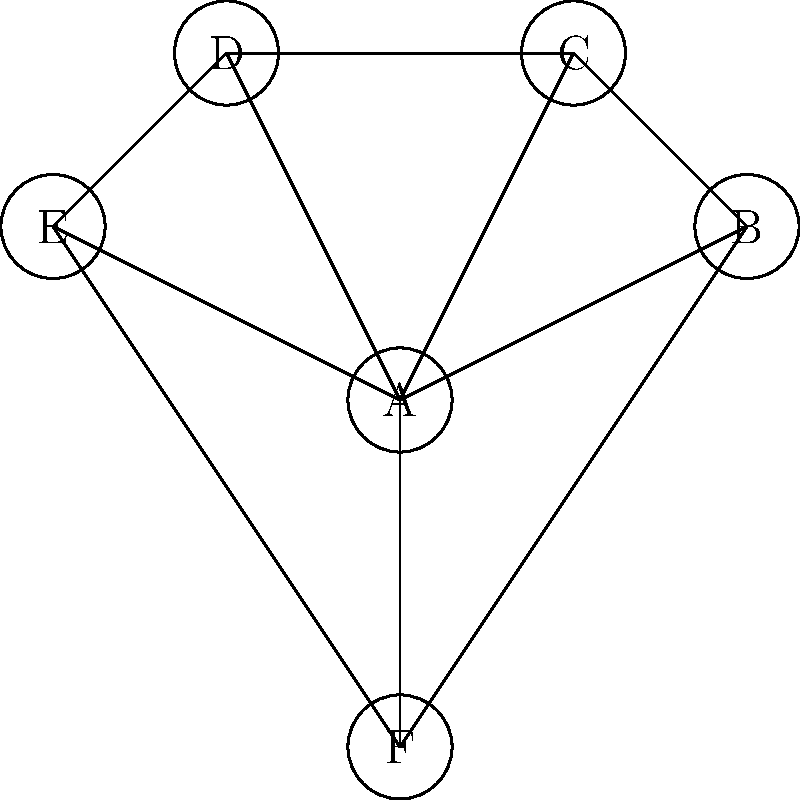In the network graph of drug interactions for a custom compounded medication, drug A is the primary active ingredient. If we remove drug A from the formulation, how many disconnected components will the remaining graph have? To solve this problem, we need to follow these steps:

1. Understand the current graph structure:
   - The graph has 6 nodes (drugs A, B, C, D, E, and F).
   - Drug A is connected to all other drugs (B, C, D, E, and F).
   - The remaining drugs form a cycle: B-C-D-E-F-B.

2. Analyze the graph after removing drug A:
   - Removing A will eliminate all edges connected to A.
   - The remaining edges will be those forming the cycle B-C-D-E-F-B.

3. Count the number of disconnected components:
   - After removing A, we are left with a single cycle containing drugs B, C, D, E, and F.
   - This cycle forms one connected component.

4. Conclude:
   - The removal of drug A leaves us with only one disconnected component (the cycle B-C-D-E-F-B).

Therefore, after removing drug A, the remaining graph will have 1 disconnected component.
Answer: 1 